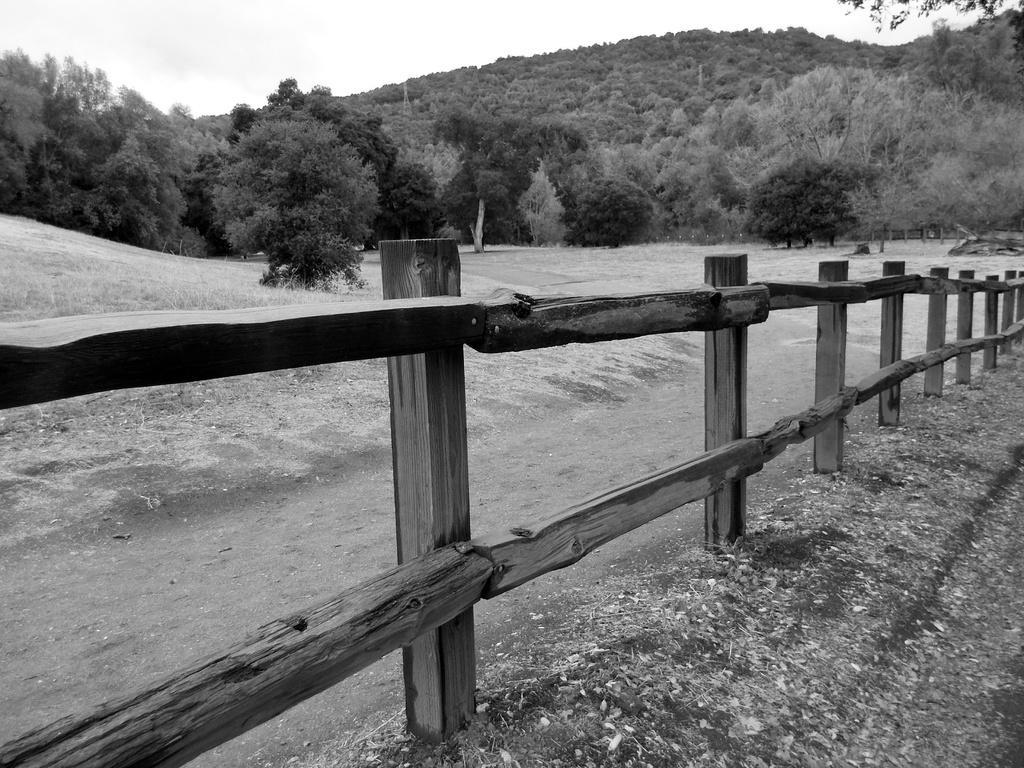Can you describe this image briefly? In this image in the front there is a wooden fence. In the background there are trees. 